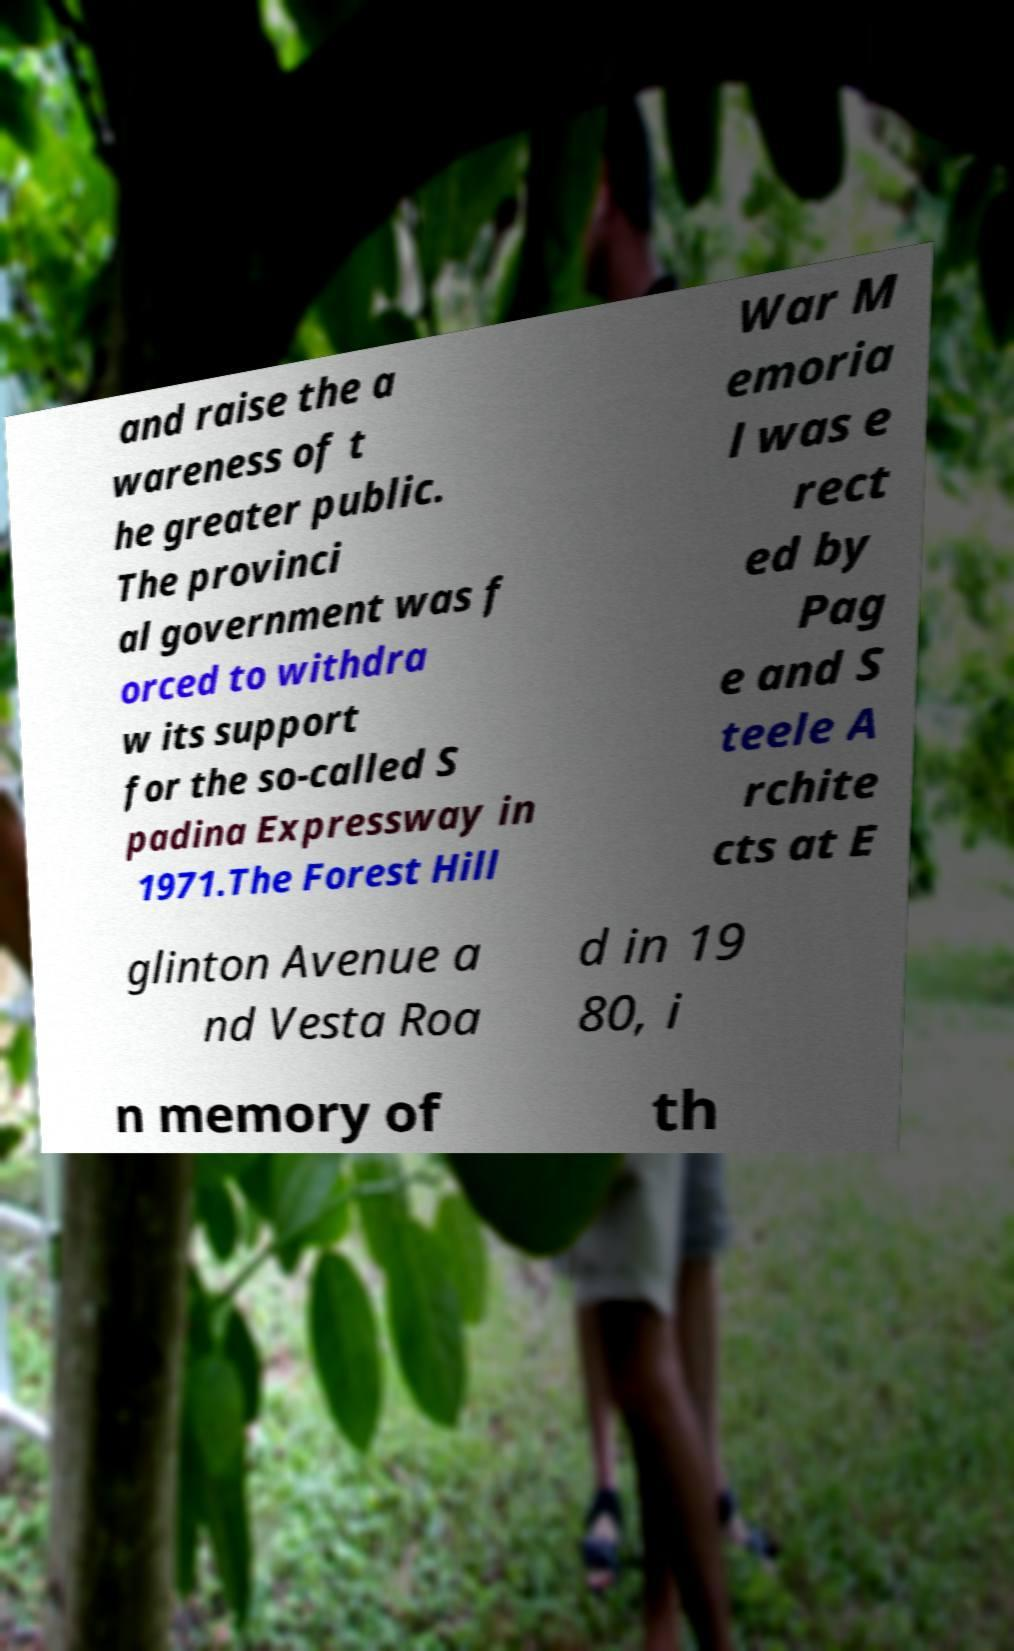Please read and relay the text visible in this image. What does it say? and raise the a wareness of t he greater public. The provinci al government was f orced to withdra w its support for the so-called S padina Expressway in 1971.The Forest Hill War M emoria l was e rect ed by Pag e and S teele A rchite cts at E glinton Avenue a nd Vesta Roa d in 19 80, i n memory of th 